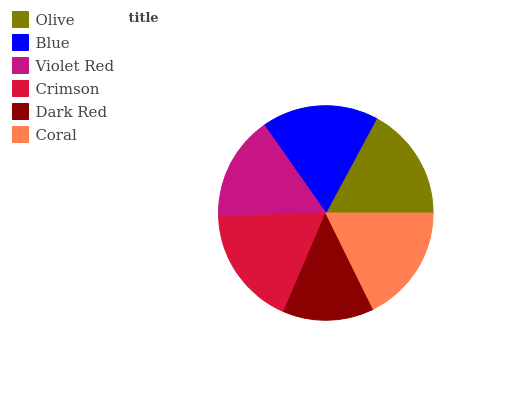Is Dark Red the minimum?
Answer yes or no. Yes. Is Crimson the maximum?
Answer yes or no. Yes. Is Blue the minimum?
Answer yes or no. No. Is Blue the maximum?
Answer yes or no. No. Is Blue greater than Olive?
Answer yes or no. Yes. Is Olive less than Blue?
Answer yes or no. Yes. Is Olive greater than Blue?
Answer yes or no. No. Is Blue less than Olive?
Answer yes or no. No. Is Blue the high median?
Answer yes or no. Yes. Is Olive the low median?
Answer yes or no. Yes. Is Coral the high median?
Answer yes or no. No. Is Coral the low median?
Answer yes or no. No. 